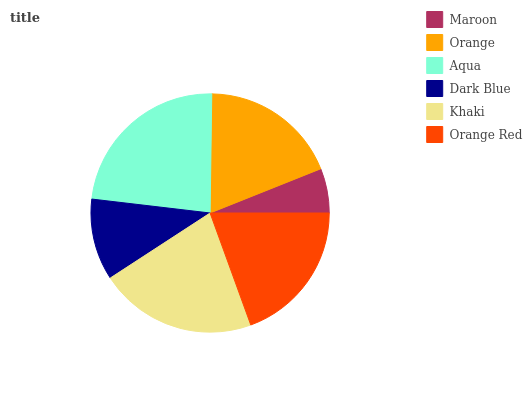Is Maroon the minimum?
Answer yes or no. Yes. Is Aqua the maximum?
Answer yes or no. Yes. Is Orange the minimum?
Answer yes or no. No. Is Orange the maximum?
Answer yes or no. No. Is Orange greater than Maroon?
Answer yes or no. Yes. Is Maroon less than Orange?
Answer yes or no. Yes. Is Maroon greater than Orange?
Answer yes or no. No. Is Orange less than Maroon?
Answer yes or no. No. Is Orange Red the high median?
Answer yes or no. Yes. Is Orange the low median?
Answer yes or no. Yes. Is Aqua the high median?
Answer yes or no. No. Is Aqua the low median?
Answer yes or no. No. 